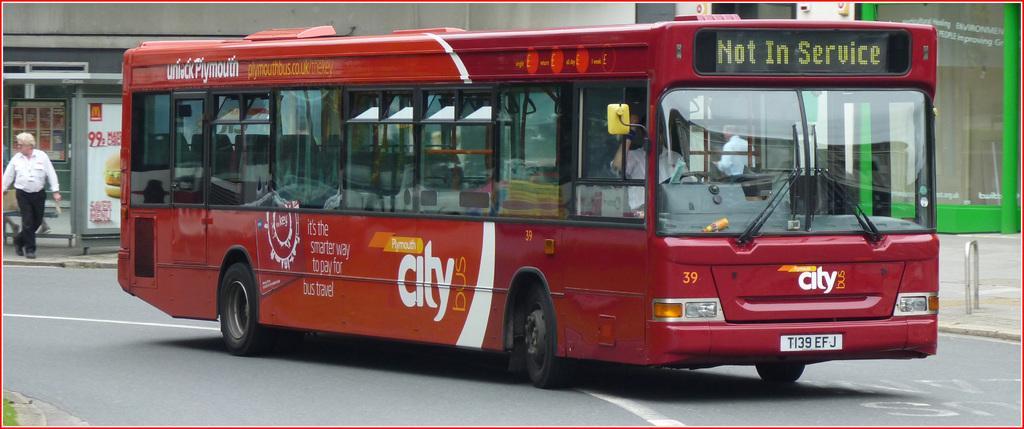In one or two sentences, can you explain what this image depicts? In this image there is a bus on the road, beside the road on the pavement there are a few people walking and there are metal rods, bus stop, display boards and buildings 